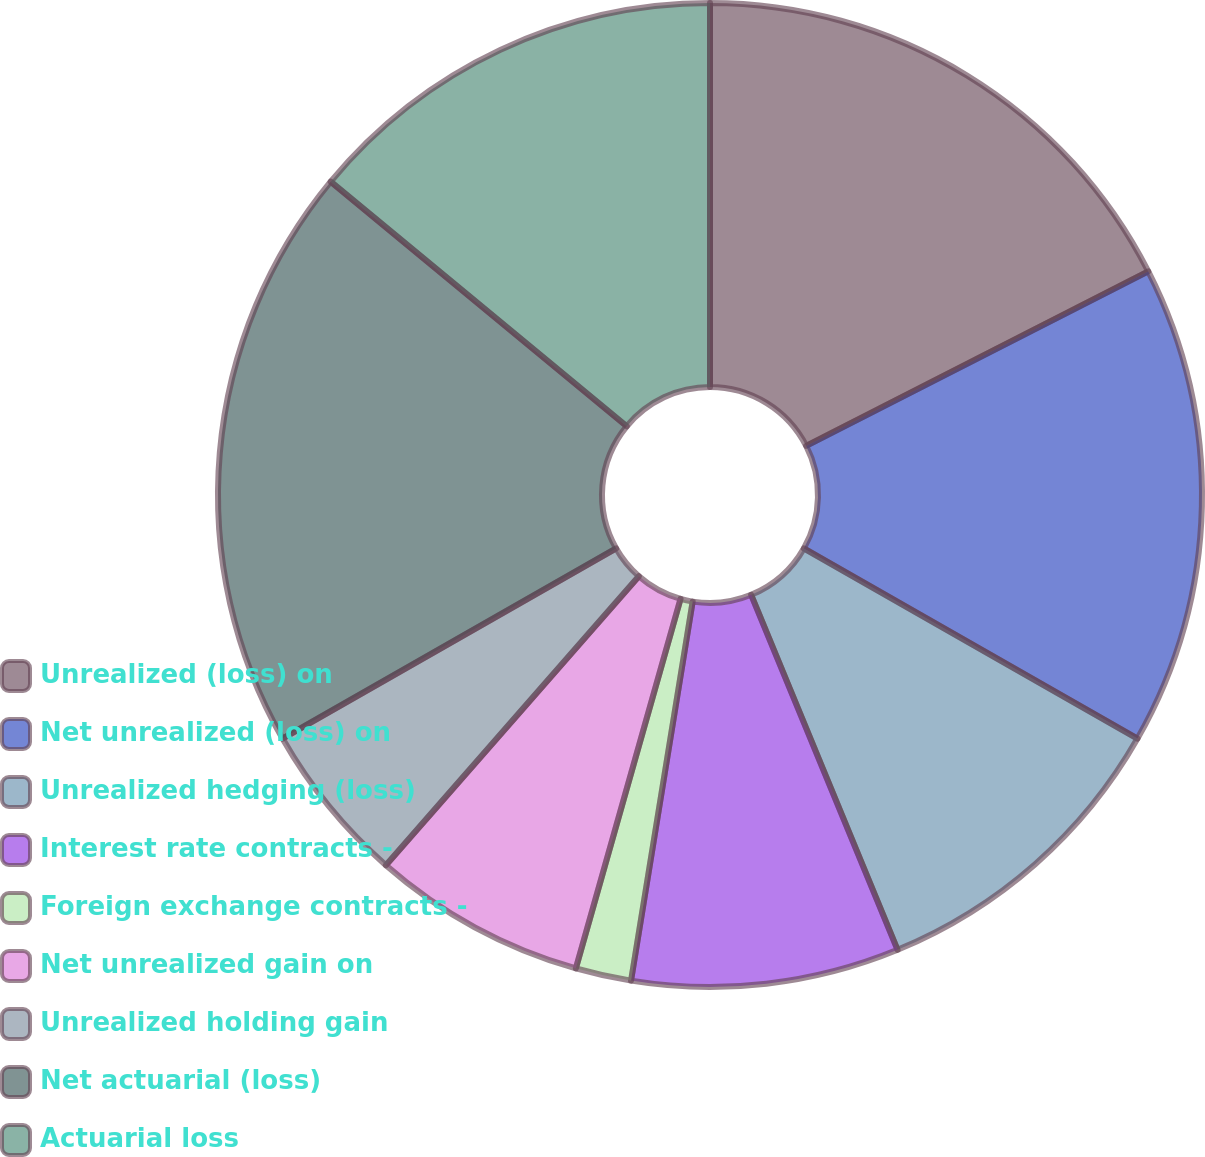<chart> <loc_0><loc_0><loc_500><loc_500><pie_chart><fcel>Unrealized (loss) on<fcel>Net unrealized (loss) on<fcel>Unrealized hedging (loss)<fcel>Interest rate contracts -<fcel>Foreign exchange contracts -<fcel>Net unrealized gain on<fcel>Unrealized holding gain<fcel>Net actuarial (loss)<fcel>Actuarial loss<nl><fcel>17.49%<fcel>15.75%<fcel>10.53%<fcel>8.79%<fcel>1.83%<fcel>7.05%<fcel>5.31%<fcel>19.23%<fcel>14.01%<nl></chart> 